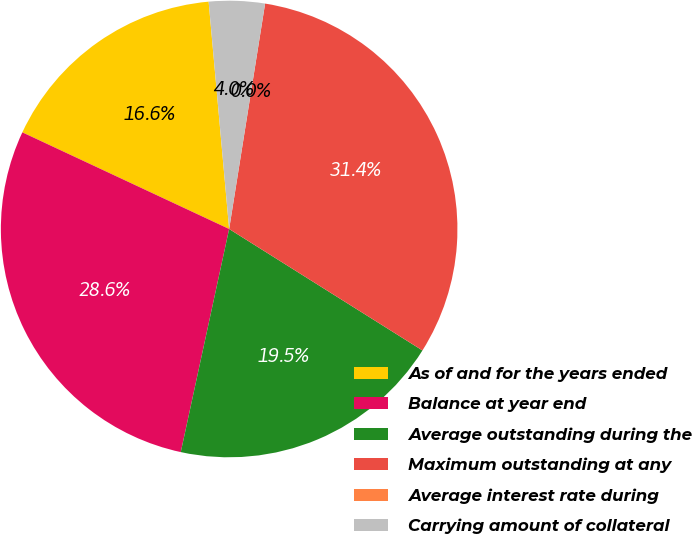Convert chart. <chart><loc_0><loc_0><loc_500><loc_500><pie_chart><fcel>As of and for the years ended<fcel>Balance at year end<fcel>Average outstanding during the<fcel>Maximum outstanding at any<fcel>Average interest rate during<fcel>Carrying amount of collateral<nl><fcel>16.61%<fcel>28.56%<fcel>19.47%<fcel>31.41%<fcel>0.0%<fcel>3.95%<nl></chart> 